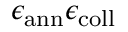<formula> <loc_0><loc_0><loc_500><loc_500>\epsilon _ { a n n } \epsilon _ { c o l l }</formula> 